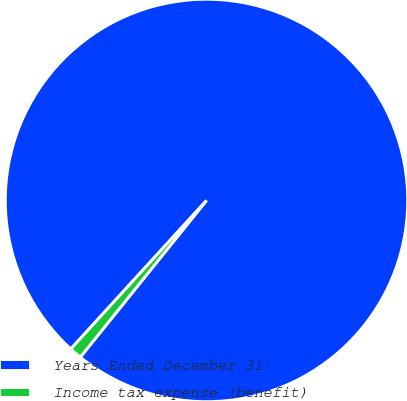Convert chart to OTSL. <chart><loc_0><loc_0><loc_500><loc_500><pie_chart><fcel>Years Ended December 31<fcel>Income tax expense (benefit)<nl><fcel>99.01%<fcel>0.99%<nl></chart> 